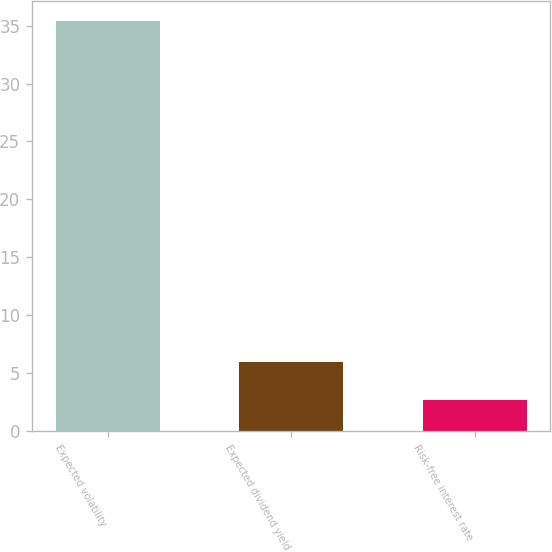<chart> <loc_0><loc_0><loc_500><loc_500><bar_chart><fcel>Expected volatility<fcel>Expected dividend yield<fcel>Risk-free interest rate<nl><fcel>35.39<fcel>5.92<fcel>2.64<nl></chart> 